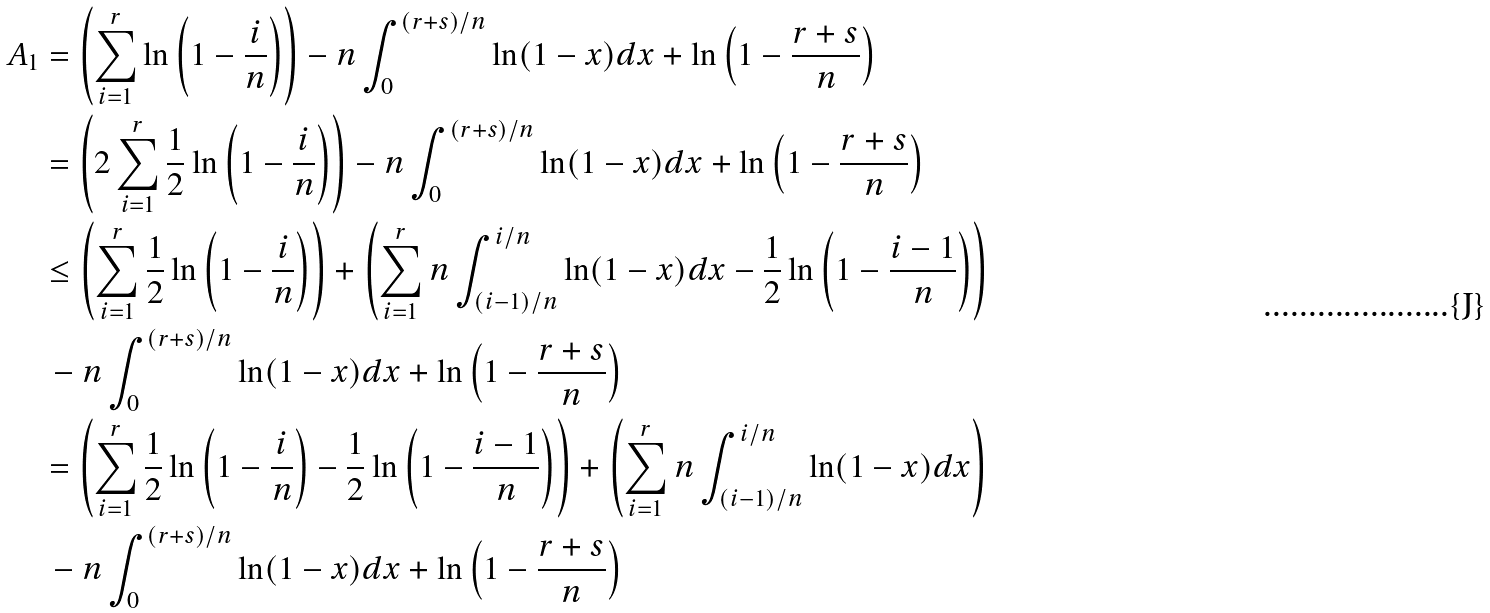<formula> <loc_0><loc_0><loc_500><loc_500>A _ { 1 } & = \left ( \sum _ { i = 1 } ^ { r } \ln \left ( 1 - \frac { i } { n } \right ) \right ) - n \int _ { 0 } ^ { ( r + s ) / n } \ln ( 1 - x ) d x + \ln \left ( 1 - \frac { r + s } { n } \right ) \\ & = \left ( 2 \sum _ { i = 1 } ^ { r } \frac { 1 } { 2 } \ln \left ( 1 - \frac { i } { n } \right ) \right ) - n \int _ { 0 } ^ { ( r + s ) / n } \ln ( 1 - x ) d x + \ln \left ( 1 - \frac { r + s } { n } \right ) \\ & \leq \left ( \sum _ { i = 1 } ^ { r } \frac { 1 } { 2 } \ln \left ( 1 - \frac { i } { n } \right ) \right ) + \left ( \sum _ { i = 1 } ^ { r } n \int _ { ( i - 1 ) / n } ^ { i / n } \ln ( 1 - x ) d x - \frac { 1 } { 2 } \ln \left ( 1 - \frac { i - 1 } { n } \right ) \right ) \\ & \, - n \int _ { 0 } ^ { ( r + s ) / n } \ln ( 1 - x ) d x + \ln \left ( 1 - \frac { r + s } { n } \right ) \\ & = \left ( \sum _ { i = 1 } ^ { r } \frac { 1 } { 2 } \ln \left ( 1 - \frac { i } { n } \right ) - \frac { 1 } { 2 } \ln \left ( 1 - \frac { i - 1 } { n } \right ) \right ) + \left ( \sum _ { i = 1 } ^ { r } n \int _ { ( i - 1 ) / n } ^ { i / n } \ln ( 1 - x ) d x \right ) \\ & \, - n \int _ { 0 } ^ { ( r + s ) / n } \ln ( 1 - x ) d x + \ln \left ( 1 - \frac { r + s } { n } \right )</formula> 